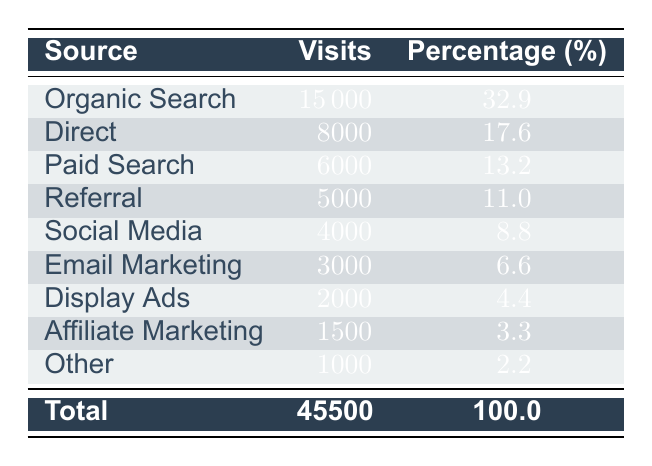What is the total number of visits recorded for the year 2023? The table indicates a total row at the bottom, stating the total visits. It shows that the total number of visits is 45500.
Answer: 45500 Which traffic source had the highest number of visits? The table clearly lists the sources and their corresponding visits. The source with the highest visits is Organic Search with 15000 visits.
Answer: Organic Search What percentage of total visits come from Email Marketing? Email Marketing has 3000 visits. To find the percentage, we calculate (3000/45500) * 100, which equals approximately 6.6%. The table confirms this data.
Answer: 6.6% Is the number of visits from Direct higher than the number of visits from Referral? The table shows Direct has 8000 visits while Referral has 5000 visits. Since 8000 is greater than 5000, the answer is yes.
Answer: Yes How many visits are there from Paid Search and Social Media combined? Paid Search has 6000 visits and Social Media has 4000 visits. By adding these together, 6000 + 4000 = 10000 visits in total from both sources.
Answer: 10000 Which two sources reported the lowest traffic? The table lists the sources along with their visits. The sources with the lowest visits are Affiliate Marketing with 1500 visits and Other with 1000 visits.
Answer: Affiliate Marketing and Other What is the difference in visits between Organic Search and Paid Search? Organic Search has 15000 visits, and Paid Search has 6000 visits. The difference is calculated as 15000 - 6000 = 9000 visits.
Answer: 9000 What percentage of the total visits comes from the three highest traffic sources combined? The three highest sources—Organic Search (15000), Direct (8000), and Paid Search (6000)—total 15000 + 8000 + 6000 = 29000 visits. The percentage is (29000/45500) * 100, which is approximately 63.7%.
Answer: 63.7% Are there more visits from Social Media than from Display Ads? Social Media has 4000 visits while Display Ads has 2000 visits. Since 4000 is greater than 2000, the answer is yes.
Answer: Yes 